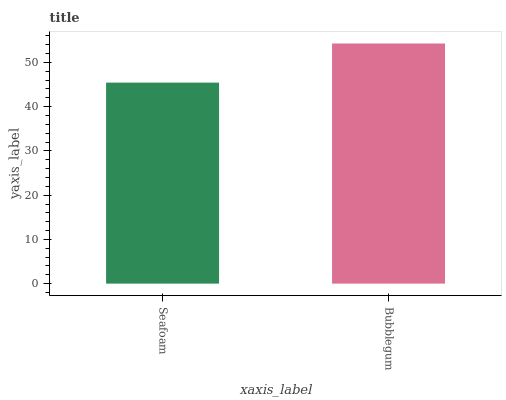Is Seafoam the minimum?
Answer yes or no. Yes. Is Bubblegum the maximum?
Answer yes or no. Yes. Is Bubblegum the minimum?
Answer yes or no. No. Is Bubblegum greater than Seafoam?
Answer yes or no. Yes. Is Seafoam less than Bubblegum?
Answer yes or no. Yes. Is Seafoam greater than Bubblegum?
Answer yes or no. No. Is Bubblegum less than Seafoam?
Answer yes or no. No. Is Bubblegum the high median?
Answer yes or no. Yes. Is Seafoam the low median?
Answer yes or no. Yes. Is Seafoam the high median?
Answer yes or no. No. Is Bubblegum the low median?
Answer yes or no. No. 